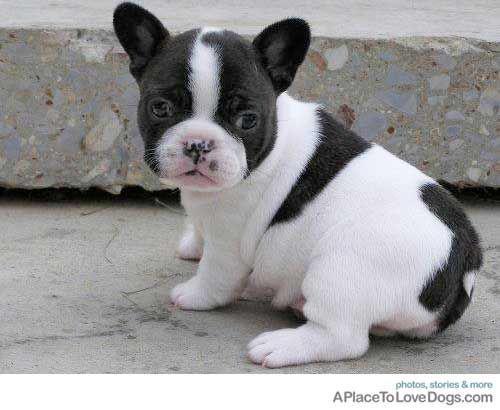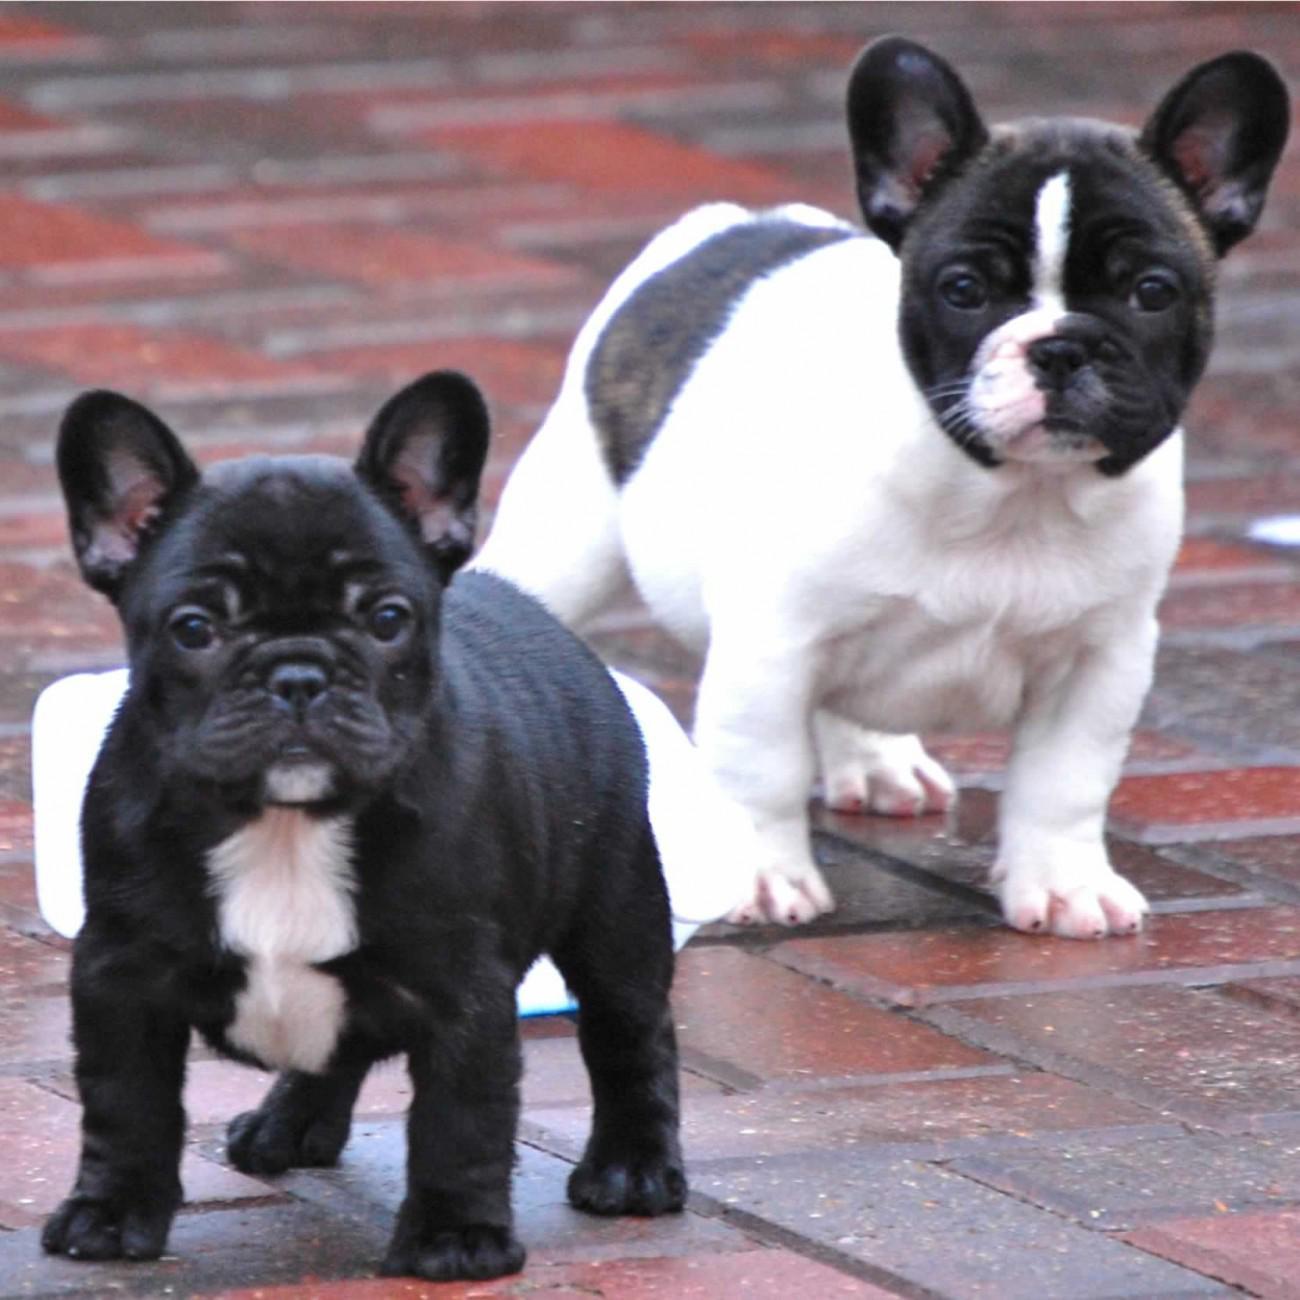The first image is the image on the left, the second image is the image on the right. For the images displayed, is the sentence "There are two dogs in the right image." factually correct? Answer yes or no. Yes. The first image is the image on the left, the second image is the image on the right. Analyze the images presented: Is the assertion "The right image shows two dogs, while the left image shows just one" valid? Answer yes or no. Yes. 